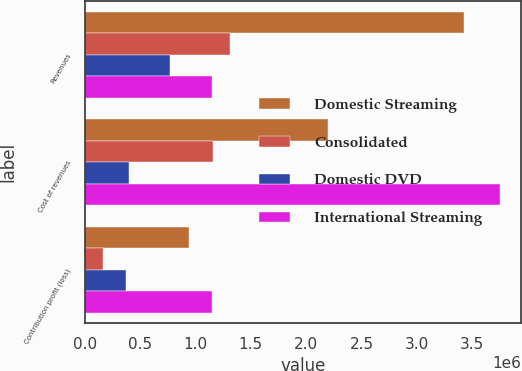Convert chart. <chart><loc_0><loc_0><loc_500><loc_500><stacked_bar_chart><ecel><fcel>Revenues<fcel>Cost of revenues<fcel>Contribution profit (loss)<nl><fcel>Domestic Streaming<fcel>3.43143e+06<fcel>2.20176e+06<fcel>936220<nl><fcel>Consolidated<fcel>1.30806e+06<fcel>1.15412e+06<fcel>159789<nl><fcel>Domestic DVD<fcel>765161<fcel>396882<fcel>368279<nl><fcel>International Streaming<fcel>1.14471e+06<fcel>3.75276e+06<fcel>1.14471e+06<nl></chart> 